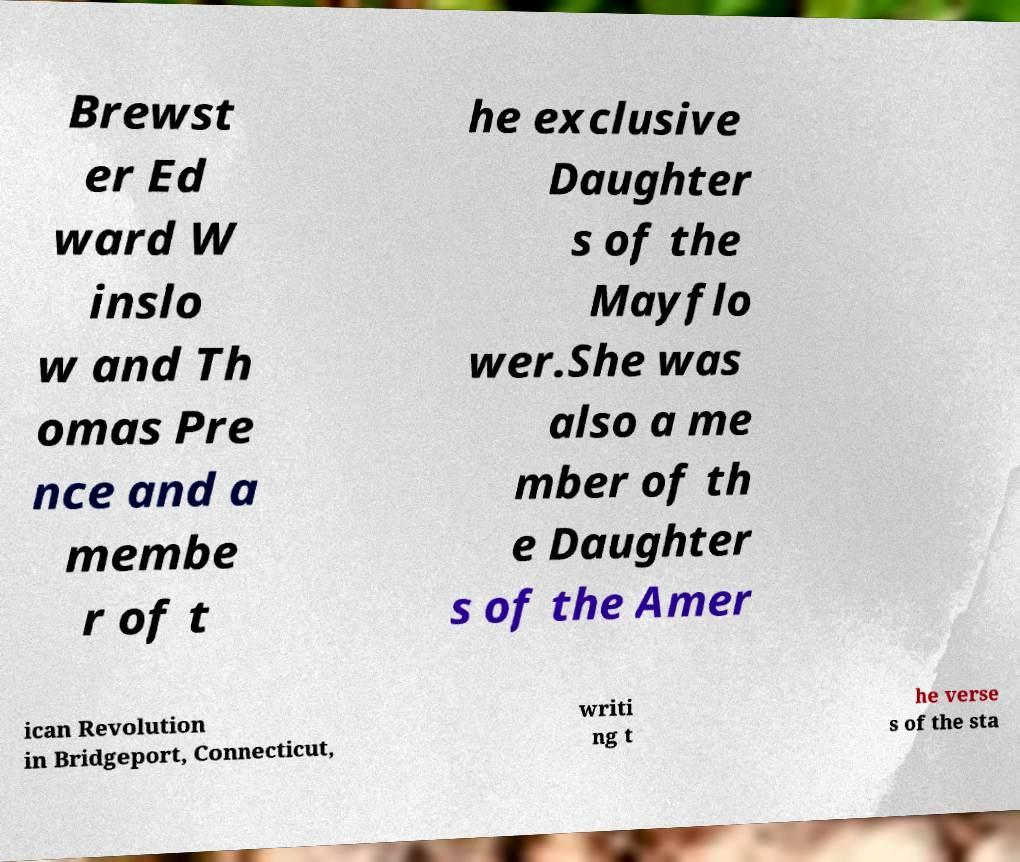Please read and relay the text visible in this image. What does it say? Brewst er Ed ward W inslo w and Th omas Pre nce and a membe r of t he exclusive Daughter s of the Mayflo wer.She was also a me mber of th e Daughter s of the Amer ican Revolution in Bridgeport, Connecticut, writi ng t he verse s of the sta 